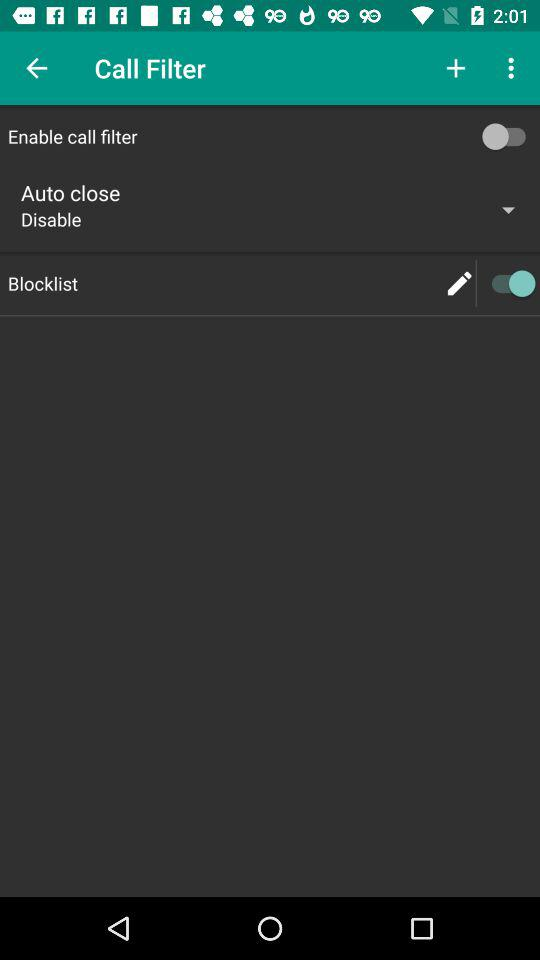What is the status of "Blocklist"? The status is "on". 